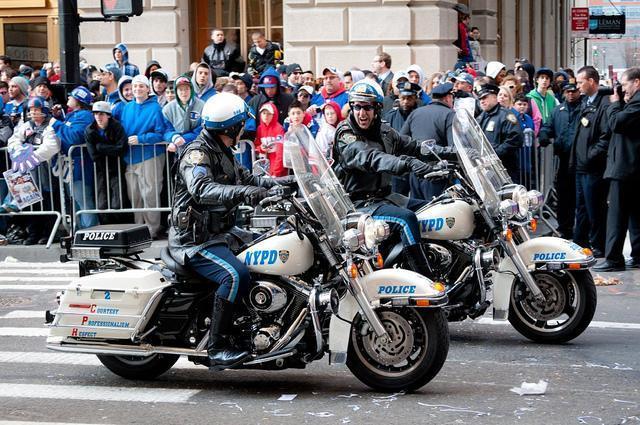How many motorcycles are there?
Give a very brief answer. 2. How many people are there?
Give a very brief answer. 11. How many motorcycles are in the photo?
Give a very brief answer. 2. 